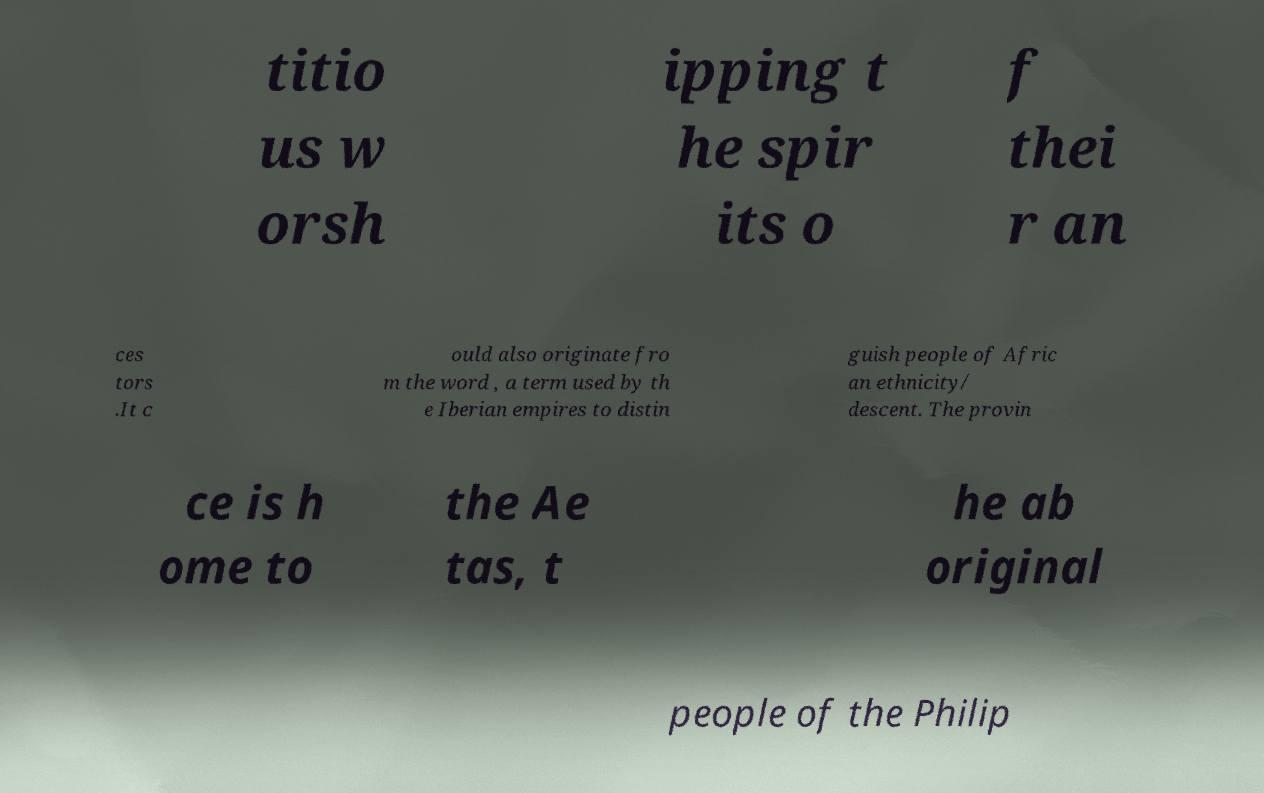Could you assist in decoding the text presented in this image and type it out clearly? titio us w orsh ipping t he spir its o f thei r an ces tors .It c ould also originate fro m the word , a term used by th e Iberian empires to distin guish people of Afric an ethnicity/ descent. The provin ce is h ome to the Ae tas, t he ab original people of the Philip 